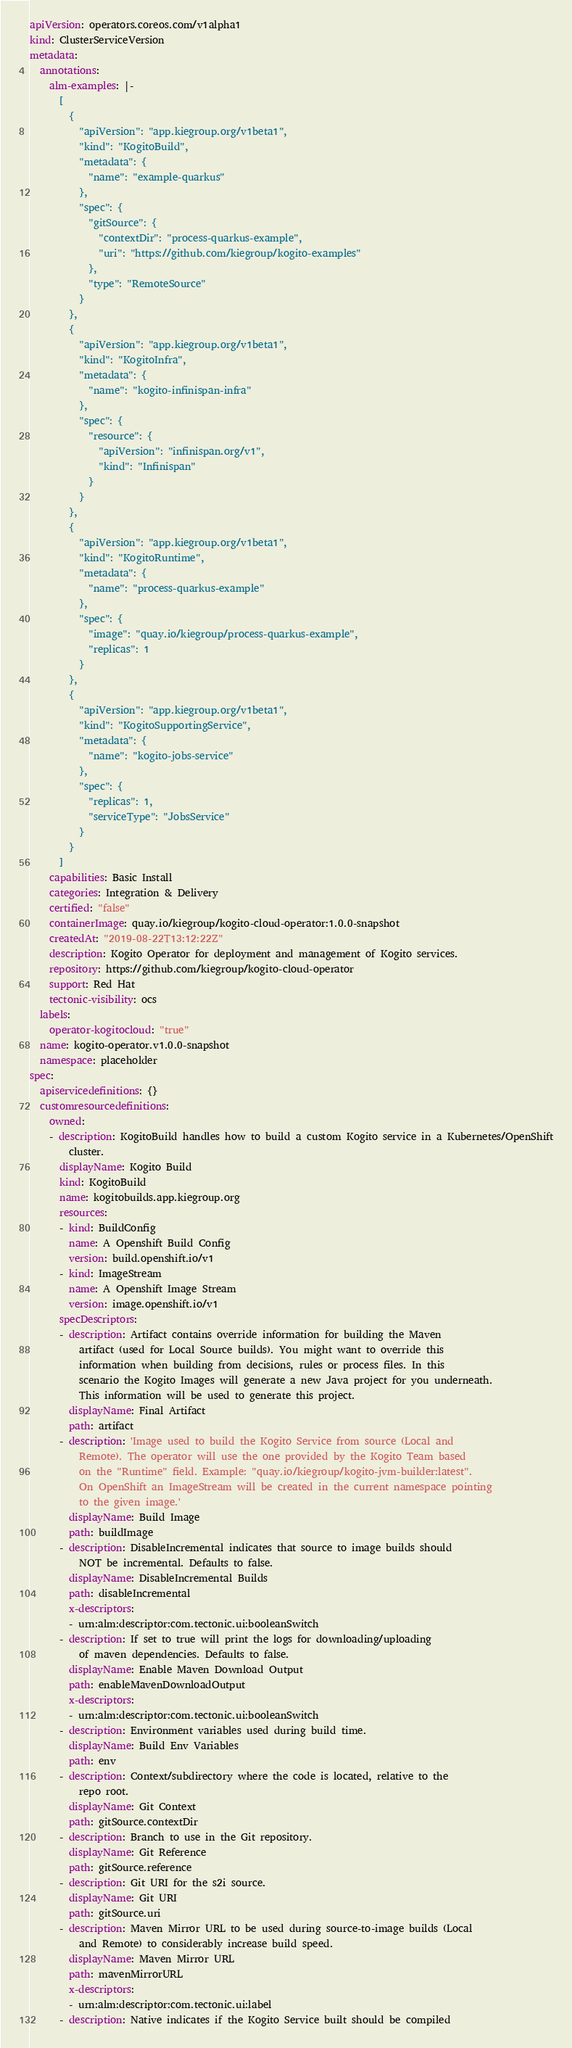Convert code to text. <code><loc_0><loc_0><loc_500><loc_500><_YAML_>apiVersion: operators.coreos.com/v1alpha1
kind: ClusterServiceVersion
metadata:
  annotations:
    alm-examples: |-
      [
        {
          "apiVersion": "app.kiegroup.org/v1beta1",
          "kind": "KogitoBuild",
          "metadata": {
            "name": "example-quarkus"
          },
          "spec": {
            "gitSource": {
              "contextDir": "process-quarkus-example",
              "uri": "https://github.com/kiegroup/kogito-examples"
            },
            "type": "RemoteSource"
          }
        },
        {
          "apiVersion": "app.kiegroup.org/v1beta1",
          "kind": "KogitoInfra",
          "metadata": {
            "name": "kogito-infinispan-infra"
          },
          "spec": {
            "resource": {
              "apiVersion": "infinispan.org/v1",
              "kind": "Infinispan"
            }
          }
        },
        {
          "apiVersion": "app.kiegroup.org/v1beta1",
          "kind": "KogitoRuntime",
          "metadata": {
            "name": "process-quarkus-example"
          },
          "spec": {
            "image": "quay.io/kiegroup/process-quarkus-example",
            "replicas": 1
          }
        },
        {
          "apiVersion": "app.kiegroup.org/v1beta1",
          "kind": "KogitoSupportingService",
          "metadata": {
            "name": "kogito-jobs-service"
          },
          "spec": {
            "replicas": 1,
            "serviceType": "JobsService"
          }
        }
      ]
    capabilities: Basic Install
    categories: Integration & Delivery
    certified: "false"
    containerImage: quay.io/kiegroup/kogito-cloud-operator:1.0.0-snapshot
    createdAt: "2019-08-22T13:12:22Z"
    description: Kogito Operator for deployment and management of Kogito services.
    repository: https://github.com/kiegroup/kogito-cloud-operator
    support: Red Hat
    tectonic-visibility: ocs
  labels:
    operator-kogitocloud: "true"
  name: kogito-operator.v1.0.0-snapshot
  namespace: placeholder
spec:
  apiservicedefinitions: {}
  customresourcedefinitions:
    owned:
    - description: KogitoBuild handles how to build a custom Kogito service in a Kubernetes/OpenShift
        cluster.
      displayName: Kogito Build
      kind: KogitoBuild
      name: kogitobuilds.app.kiegroup.org
      resources:
      - kind: BuildConfig
        name: A Openshift Build Config
        version: build.openshift.io/v1
      - kind: ImageStream
        name: A Openshift Image Stream
        version: image.openshift.io/v1
      specDescriptors:
      - description: Artifact contains override information for building the Maven
          artifact (used for Local Source builds). You might want to override this
          information when building from decisions, rules or process files. In this
          scenario the Kogito Images will generate a new Java project for you underneath.
          This information will be used to generate this project.
        displayName: Final Artifact
        path: artifact
      - description: 'Image used to build the Kogito Service from source (Local and
          Remote). The operator will use the one provided by the Kogito Team based
          on the "Runtime" field. Example: "quay.io/kiegroup/kogito-jvm-builder:latest".
          On OpenShift an ImageStream will be created in the current namespace pointing
          to the given image.'
        displayName: Build Image
        path: buildImage
      - description: DisableIncremental indicates that source to image builds should
          NOT be incremental. Defaults to false.
        displayName: DisableIncremental Builds
        path: disableIncremental
        x-descriptors:
        - urn:alm:descriptor:com.tectonic.ui:booleanSwitch
      - description: If set to true will print the logs for downloading/uploading
          of maven dependencies. Defaults to false.
        displayName: Enable Maven Download Output
        path: enableMavenDownloadOutput
        x-descriptors:
        - urn:alm:descriptor:com.tectonic.ui:booleanSwitch
      - description: Environment variables used during build time.
        displayName: Build Env Variables
        path: env
      - description: Context/subdirectory where the code is located, relative to the
          repo root.
        displayName: Git Context
        path: gitSource.contextDir
      - description: Branch to use in the Git repository.
        displayName: Git Reference
        path: gitSource.reference
      - description: Git URI for the s2i source.
        displayName: Git URI
        path: gitSource.uri
      - description: Maven Mirror URL to be used during source-to-image builds (Local
          and Remote) to considerably increase build speed.
        displayName: Maven Mirror URL
        path: mavenMirrorURL
        x-descriptors:
        - urn:alm:descriptor:com.tectonic.ui:label
      - description: Native indicates if the Kogito Service built should be compiled</code> 